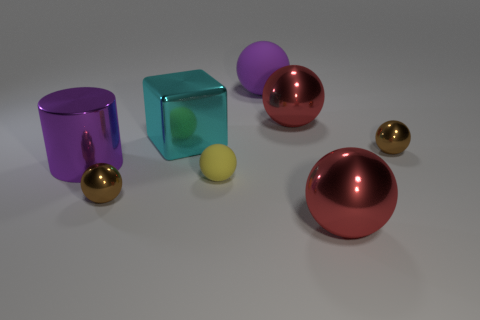The big metal thing that is in front of the big cube and left of the purple sphere is what color?
Offer a terse response. Purple. What is the small brown ball that is to the left of the small rubber ball made of?
Give a very brief answer. Metal. What is the size of the purple cylinder?
Give a very brief answer. Large. What number of red things are small metallic balls or cylinders?
Make the answer very short. 0. How big is the brown sphere in front of the brown thing right of the large purple sphere?
Your response must be concise. Small. There is a small matte sphere; is its color the same as the tiny shiny thing to the right of the big purple matte sphere?
Make the answer very short. No. How many other objects are the same material as the cylinder?
Offer a terse response. 5. There is a tiny thing that is the same material as the large purple ball; what shape is it?
Your answer should be very brief. Sphere. Is there anything else that has the same color as the big metallic block?
Your answer should be compact. No. What size is the cylinder that is the same color as the large rubber ball?
Your response must be concise. Large. 